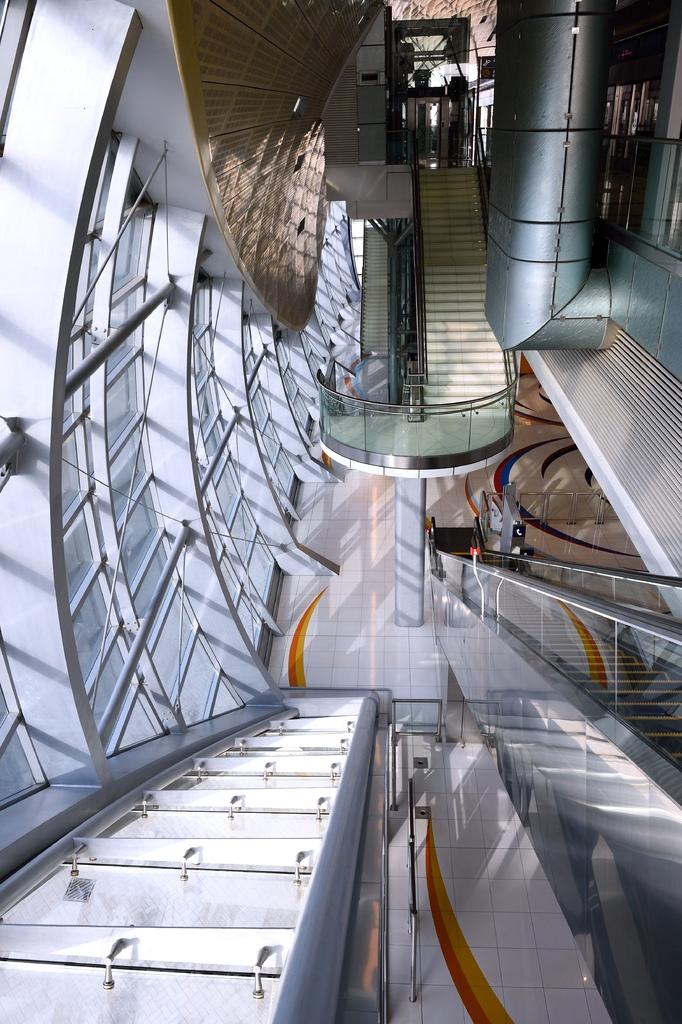What type of location is depicted in the image? The image shows an interior view of a mall. What architectural feature can be seen in the mall? There are stairs, an escalator, and a lift in the mall. What type of windows are present in the mall? There are glass windows in the mall. What type of expansion is being carried out on the mall in the image? There is no indication of any expansion being carried out in the image. Can you see the brake of the escalator in the image? The image does not show the internal mechanisms of the escalator, so it is not possible to see the brake. 